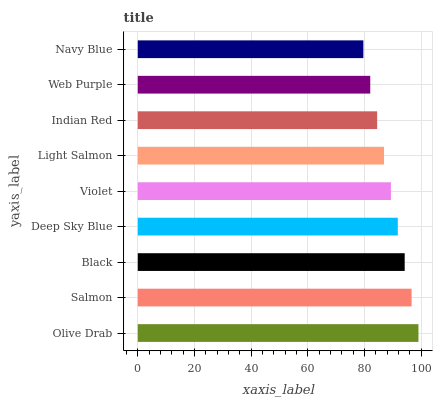Is Navy Blue the minimum?
Answer yes or no. Yes. Is Olive Drab the maximum?
Answer yes or no. Yes. Is Salmon the minimum?
Answer yes or no. No. Is Salmon the maximum?
Answer yes or no. No. Is Olive Drab greater than Salmon?
Answer yes or no. Yes. Is Salmon less than Olive Drab?
Answer yes or no. Yes. Is Salmon greater than Olive Drab?
Answer yes or no. No. Is Olive Drab less than Salmon?
Answer yes or no. No. Is Violet the high median?
Answer yes or no. Yes. Is Violet the low median?
Answer yes or no. Yes. Is Navy Blue the high median?
Answer yes or no. No. Is Navy Blue the low median?
Answer yes or no. No. 